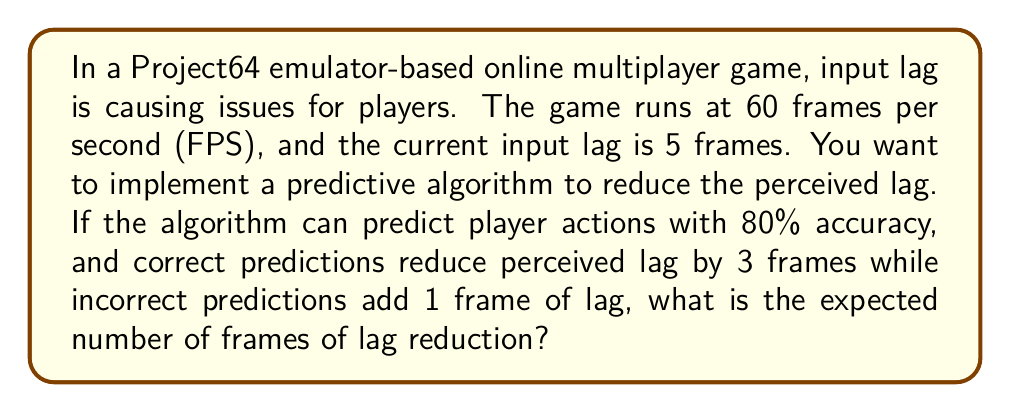Can you answer this question? Let's approach this step-by-step:

1) First, we need to define our variables:
   $p$ = probability of correct prediction = 0.8
   $q$ = probability of incorrect prediction = 1 - $p$ = 0.2
   $r$ = lag reduction for correct prediction = 3 frames
   $s$ = lag increase for incorrect prediction = 1 frame

2) We can model this as an expected value problem. The expected value of lag reduction is:

   $E(\text{lag reduction}) = p \cdot r + q \cdot (-s)$

3) Substituting our values:

   $E(\text{lag reduction}) = 0.8 \cdot 3 + 0.2 \cdot (-1)$

4) Calculating:

   $E(\text{lag reduction}) = 2.4 - 0.2 = 2.2$

5) Therefore, the expected lag reduction is 2.2 frames.

6) To verify if this is indeed more efficient, we compare it to the original lag:
   Original lag: 5 frames
   Expected lag after algorithm: $5 - 2.2 = 2.8$ frames

   This is indeed an improvement, reducing the average lag by 44%.
Answer: The expected number of frames of lag reduction is 2.2 frames. 